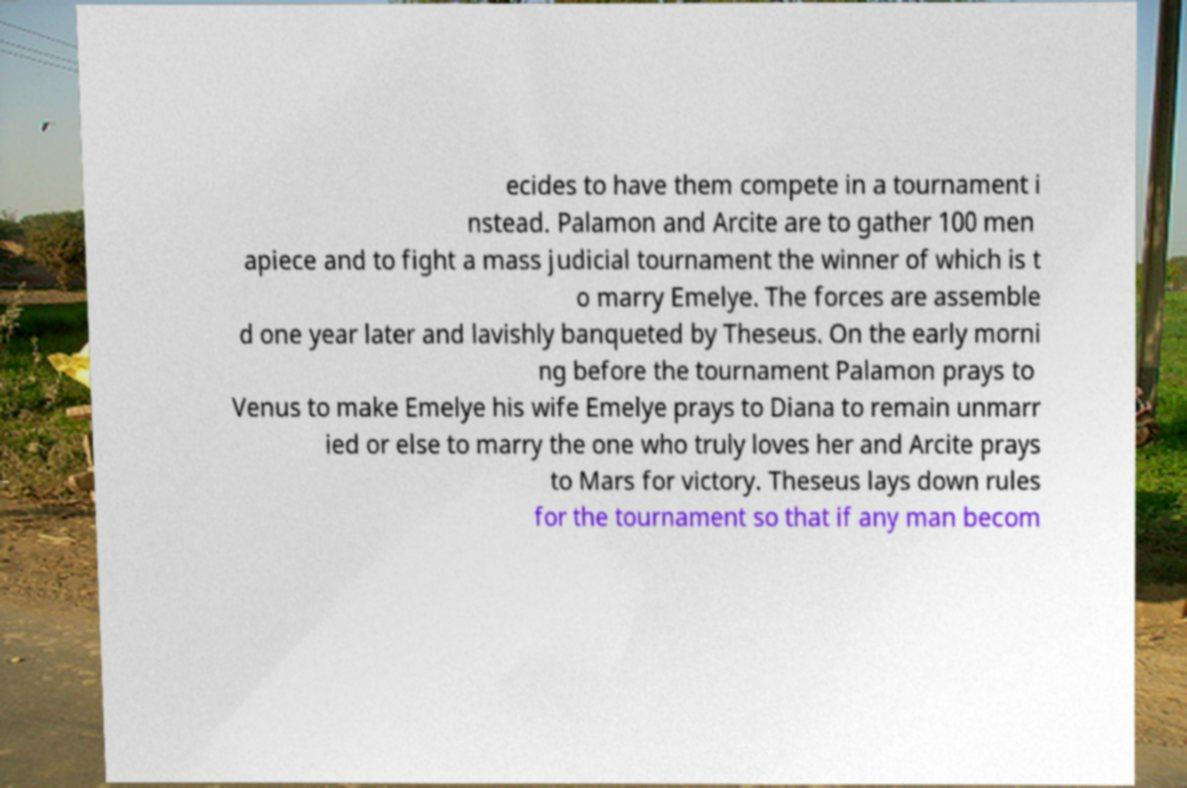Could you extract and type out the text from this image? ecides to have them compete in a tournament i nstead. Palamon and Arcite are to gather 100 men apiece and to fight a mass judicial tournament the winner of which is t o marry Emelye. The forces are assemble d one year later and lavishly banqueted by Theseus. On the early morni ng before the tournament Palamon prays to Venus to make Emelye his wife Emelye prays to Diana to remain unmarr ied or else to marry the one who truly loves her and Arcite prays to Mars for victory. Theseus lays down rules for the tournament so that if any man becom 